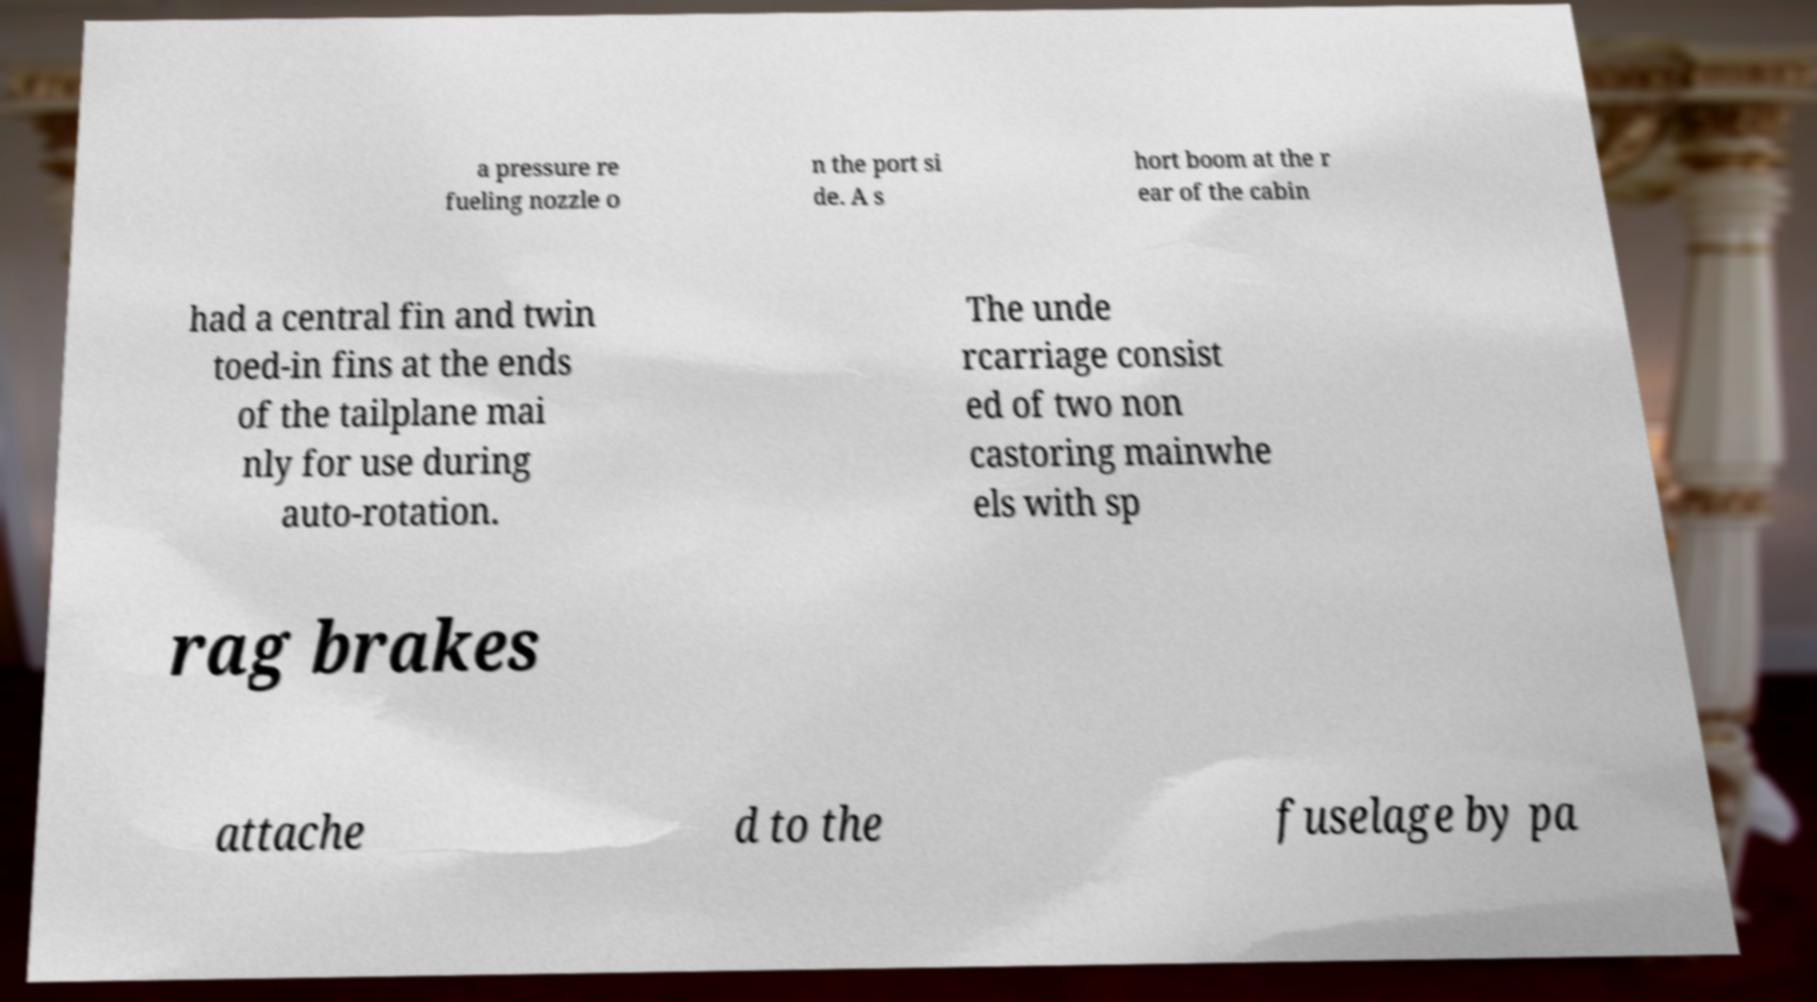I need the written content from this picture converted into text. Can you do that? a pressure re fueling nozzle o n the port si de. A s hort boom at the r ear of the cabin had a central fin and twin toed-in fins at the ends of the tailplane mai nly for use during auto-rotation. The unde rcarriage consist ed of two non castoring mainwhe els with sp rag brakes attache d to the fuselage by pa 